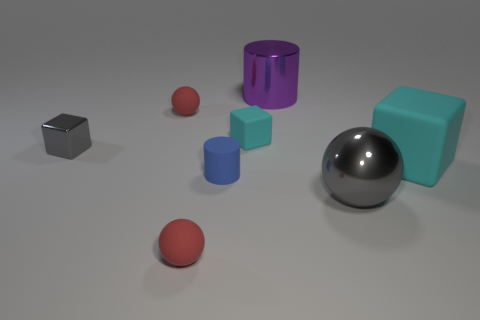What materials do the objects in the image seem to be made of? The image displays a collection of objects that seem to be made from different materials. The cube and the large ball appear to be metallic due to their reflective surfaces, while the other items—the cylinder, the small ball, and the cube—have matte surfaces which suggest they might be made of plastic or a rubber-like material. 